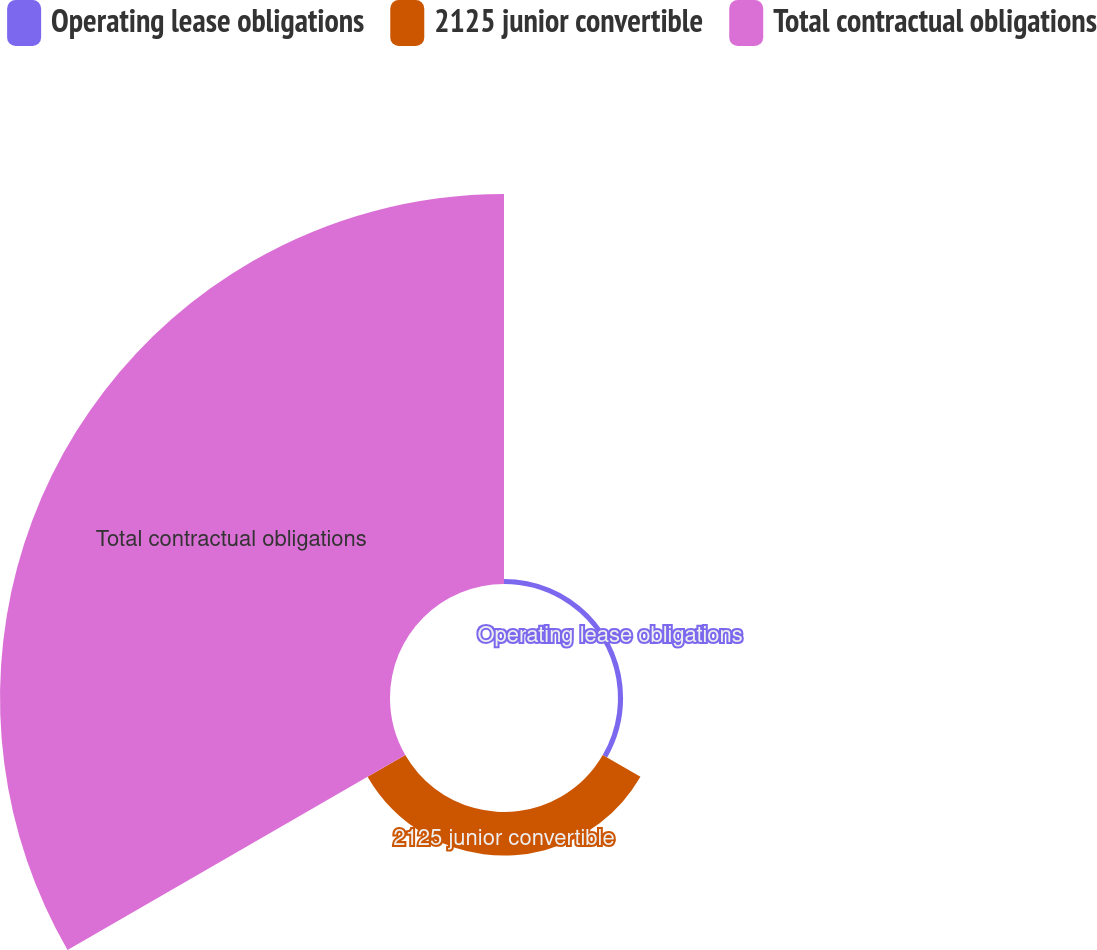Convert chart to OTSL. <chart><loc_0><loc_0><loc_500><loc_500><pie_chart><fcel>Operating lease obligations<fcel>2125 junior convertible<fcel>Total contractual obligations<nl><fcel>1.16%<fcel>9.93%<fcel>88.91%<nl></chart> 